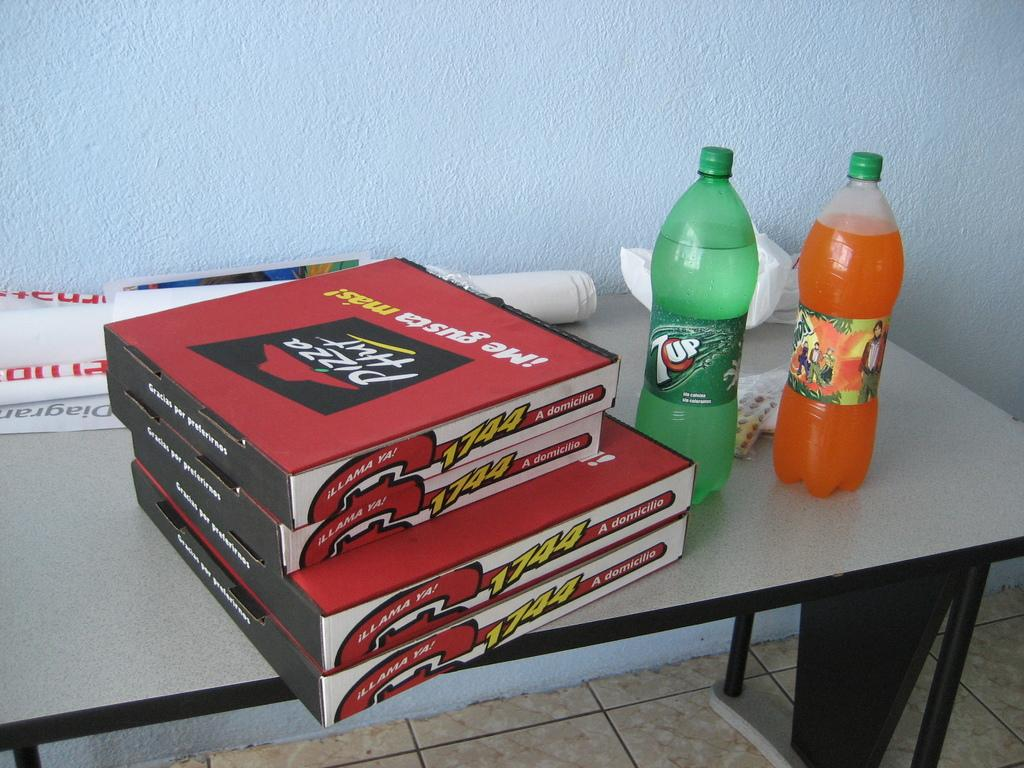What objects are on the table in the image? There are boxes, bottles, paper, and a poster on the table in the image. What can be seen on the wall in the background? Unfortunately, the facts provided do not mention anything about the wall in the background. What is visible beneath the table? The floor is visible in the image. What type of toe is depicted in the poster on the table? There is no toe depicted in the poster on the table; the poster is not mentioned to have any images of toes. 